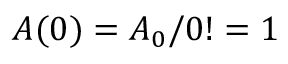Convert formula to latex. <formula><loc_0><loc_0><loc_500><loc_500>A ( 0 ) = A _ { 0 } / 0 ! = 1</formula> 